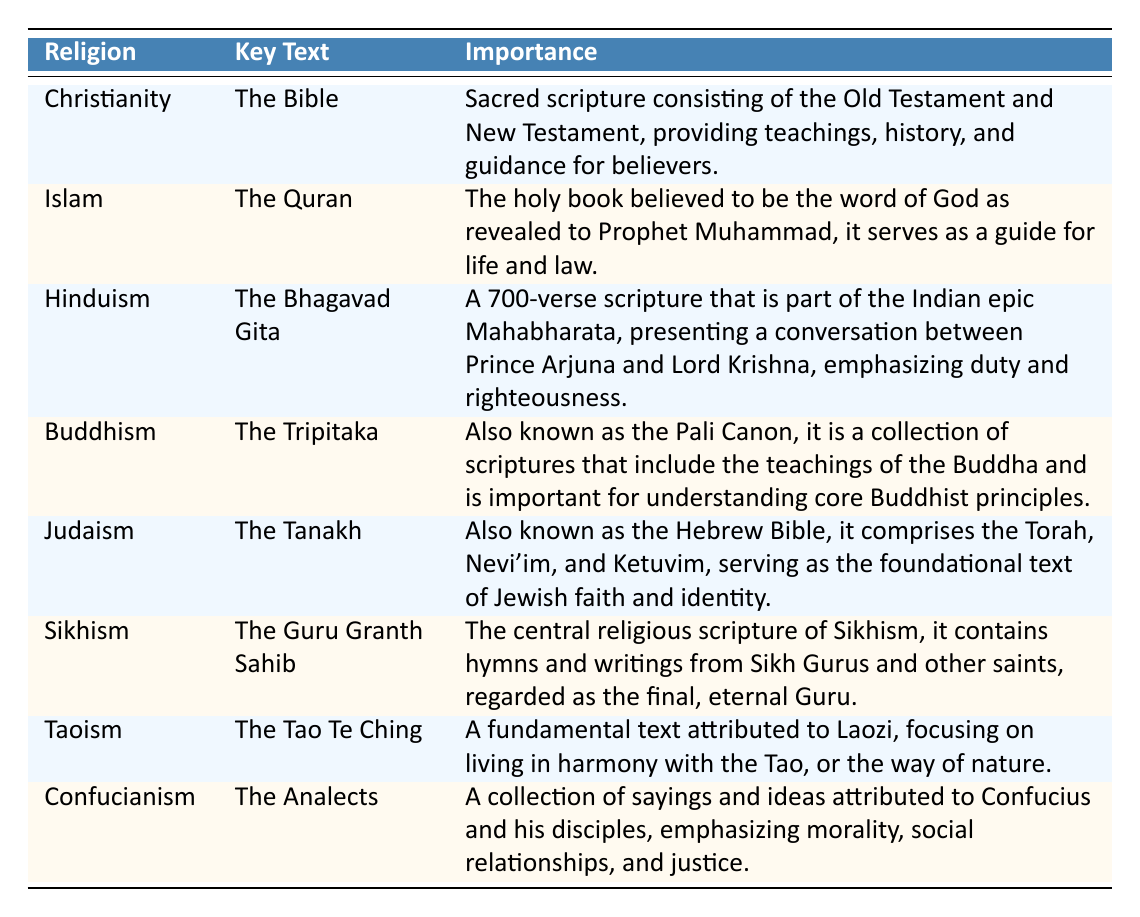What is the key text of Islam? The table lists "The Quran" as the key text for Islam. This information can be found in the row corresponding to Islam.
Answer: The Quran Which religion's key text emphasizes duty and righteousness? Referring to the table, the key text mentioning duty and righteousness is "The Bhagavad Gita," which is associated with Hinduism. This can be directly found from the Hinduism row.
Answer: Hinduism True or False: The Tanakh is known as the Hebrew Bible. According to the table, the Tanakh is described as also being known as the Hebrew Bible. This can be confirmed by reading the importance description in the Judaism row.
Answer: True What are the two parts of the Bible mentioned in the table? The table indicates that the Bible consists of the Old Testament and the New Testament. This information is found in the importance section of the Christianity row.
Answer: Old Testament and New Testament Which religious text is considered the final, eternal Guru in Sikhism? The table states that "The Guru Granth Sahib" is regarded as the final, eternal Guru of Sikhism. This is indicated in the corresponding Sikhism row.
Answer: The Guru Granth Sahib How many religions have texts emphasizing morality according to the table? The table indicates that Confucianism (with "The Analects") emphasizes morality, while Buddhism (with "The Tripitaka") emphasizes core principles that can include moral teachings. In total, Buddhism and Confucianism explicitly mention morality. This can be counted by checking the respective rows.
Answer: 2 Which text is attributed to Laozi, and what does it focus on? The table specifies that "The Tao Te Ching" is attributed to Laozi, focusing on living in harmony with the Tao. This information is directly available in the row for Taoism.
Answer: The Tao Te Ching, harmony with the Tao What is the common theme in the key texts of Buddhism and Taoism? Both Buddhism (with "The Tripitaka") and Taoism (with "The Tao Te Ching") focus on fundamental principles guiding one's life and understanding of existence. Analyzing this requires looking at both texts' emphases listed in their importance descriptions.
Answer: Fundamental life principles 